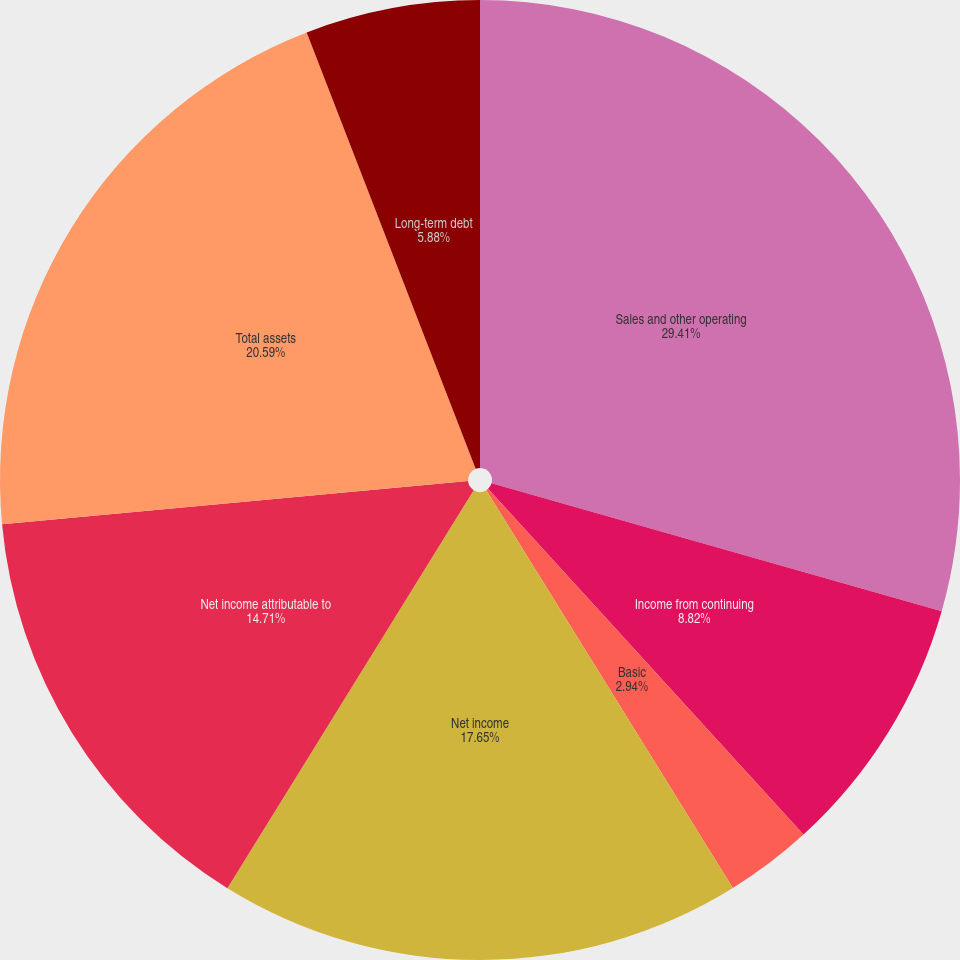Convert chart to OTSL. <chart><loc_0><loc_0><loc_500><loc_500><pie_chart><fcel>Sales and other operating<fcel>Income from continuing<fcel>Basic<fcel>Diluted<fcel>Net income<fcel>Net income attributable to<fcel>Total assets<fcel>Long-term debt<nl><fcel>29.41%<fcel>8.82%<fcel>2.94%<fcel>0.0%<fcel>17.65%<fcel>14.71%<fcel>20.59%<fcel>5.88%<nl></chart> 